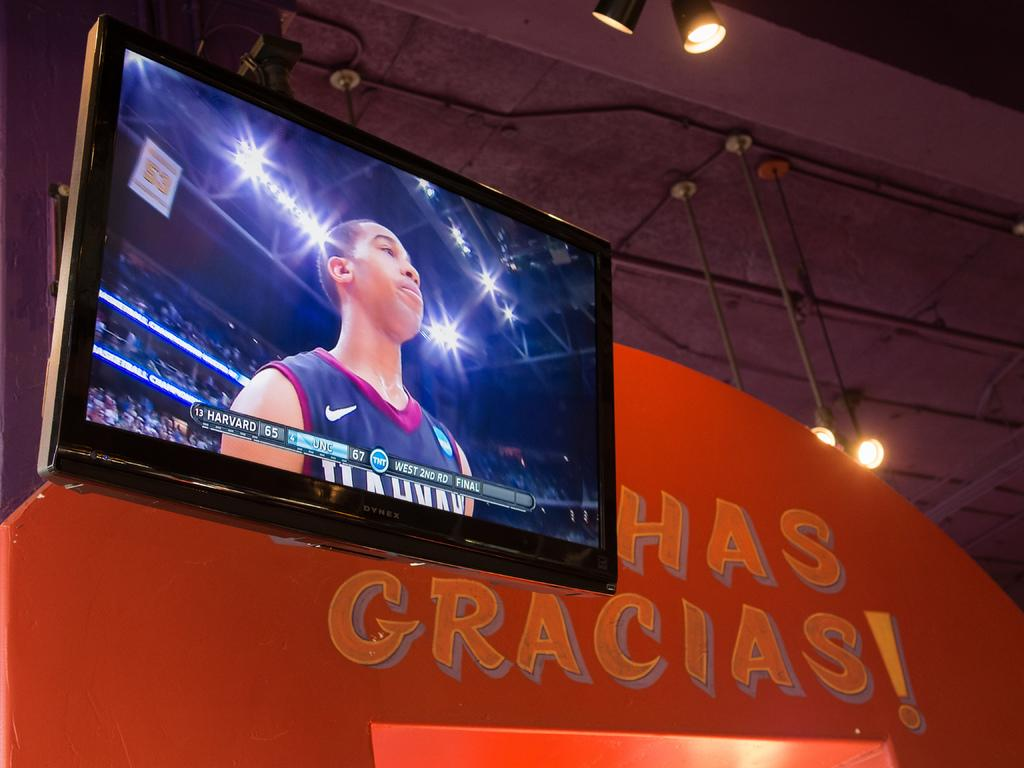<image>
Offer a succinct explanation of the picture presented. a TV screen showing a sports player and the words Harvard 65  below 